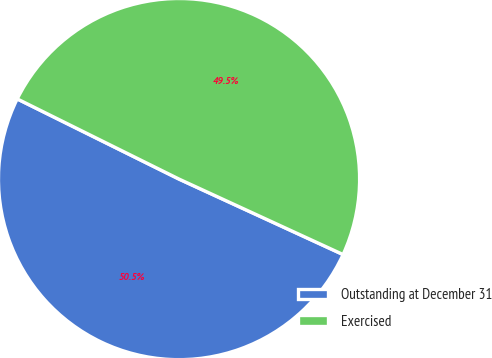<chart> <loc_0><loc_0><loc_500><loc_500><pie_chart><fcel>Outstanding at December 31<fcel>Exercised<nl><fcel>50.46%<fcel>49.54%<nl></chart> 